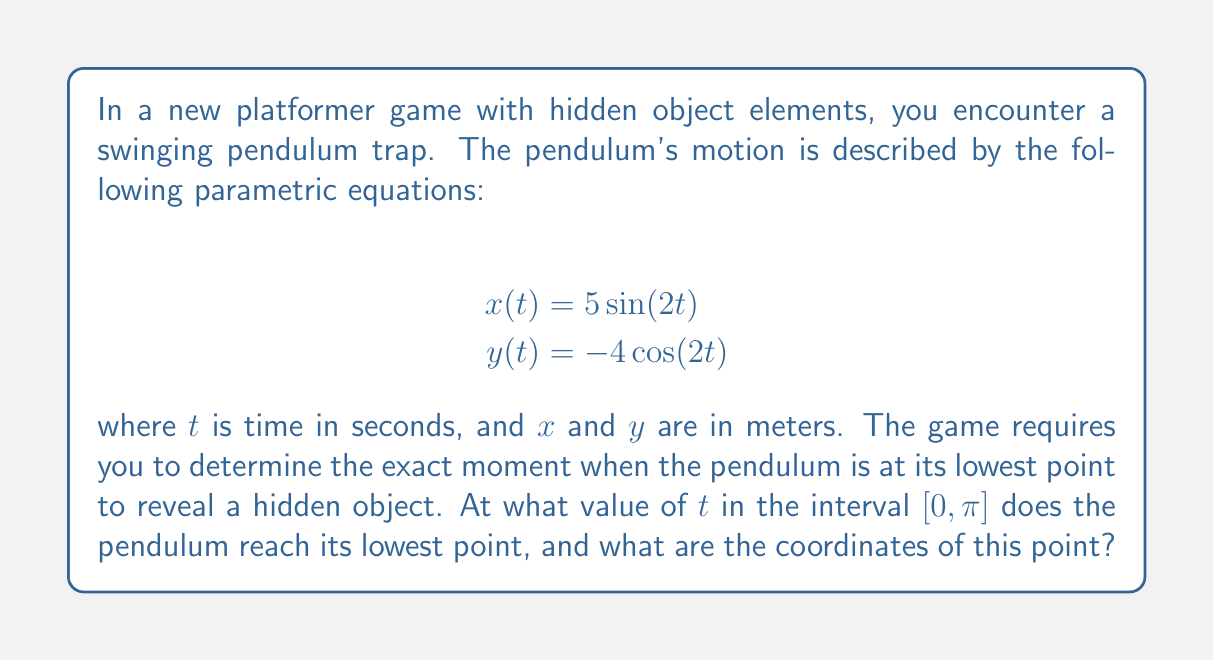Help me with this question. To solve this problem, we need to analyze the motion of the pendulum using the given parametric equations. Let's break it down step by step:

1) The lowest point of the pendulum will occur when $y(t)$ is at its minimum value.

2) Since $y(t) = -4\cos(2t)$, we need to find when $\cos(2t)$ is at its maximum value in the interval $[0, \pi]$.

3) We know that $\cos \theta$ reaches its maximum value of 1 when $\theta = 0$, $2\pi$, $4\pi$, etc.

4) In our case, we need $2t = 0$ or $2t = 2\pi$ (since $t$ is in $[0, \pi]$).

5) Solving these equations:
   $2t = 0$ gives $t = 0$
   $2t = 2\pi$ gives $t = \pi$

6) Both of these solutions are within our interval $[0, \pi]$. However, $t = 0$ gives us the maximum $y$ value (highest point), while $t = \pi$ gives us the minimum $y$ value (lowest point).

7) Therefore, the pendulum reaches its lowest point when $t = \pi$.

8) To find the coordinates of this point:

   $x(\pi) = 5\sin(2\pi) = 0$
   $y(\pi) = -4\cos(2\pi) = -4$

Thus, the coordinates of the lowest point are (0, -4).

This solution combines mathematical analysis with the game context, providing a hidden object reveal moment that depends on precise timing and observation.
Answer: The pendulum reaches its lowest point when $t = \pi$, and the coordinates of this point are (0, -4). 